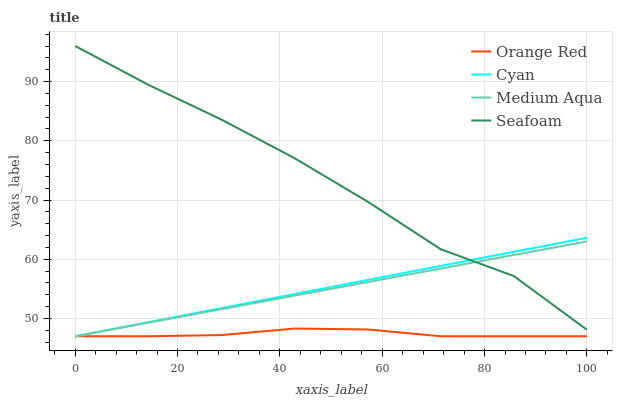Does Orange Red have the minimum area under the curve?
Answer yes or no. Yes. Does Seafoam have the maximum area under the curve?
Answer yes or no. Yes. Does Medium Aqua have the minimum area under the curve?
Answer yes or no. No. Does Medium Aqua have the maximum area under the curve?
Answer yes or no. No. Is Cyan the smoothest?
Answer yes or no. Yes. Is Seafoam the roughest?
Answer yes or no. Yes. Is Medium Aqua the smoothest?
Answer yes or no. No. Is Medium Aqua the roughest?
Answer yes or no. No. Does Cyan have the lowest value?
Answer yes or no. Yes. Does Seafoam have the lowest value?
Answer yes or no. No. Does Seafoam have the highest value?
Answer yes or no. Yes. Does Medium Aqua have the highest value?
Answer yes or no. No. Is Orange Red less than Seafoam?
Answer yes or no. Yes. Is Seafoam greater than Orange Red?
Answer yes or no. Yes. Does Cyan intersect Seafoam?
Answer yes or no. Yes. Is Cyan less than Seafoam?
Answer yes or no. No. Is Cyan greater than Seafoam?
Answer yes or no. No. Does Orange Red intersect Seafoam?
Answer yes or no. No. 